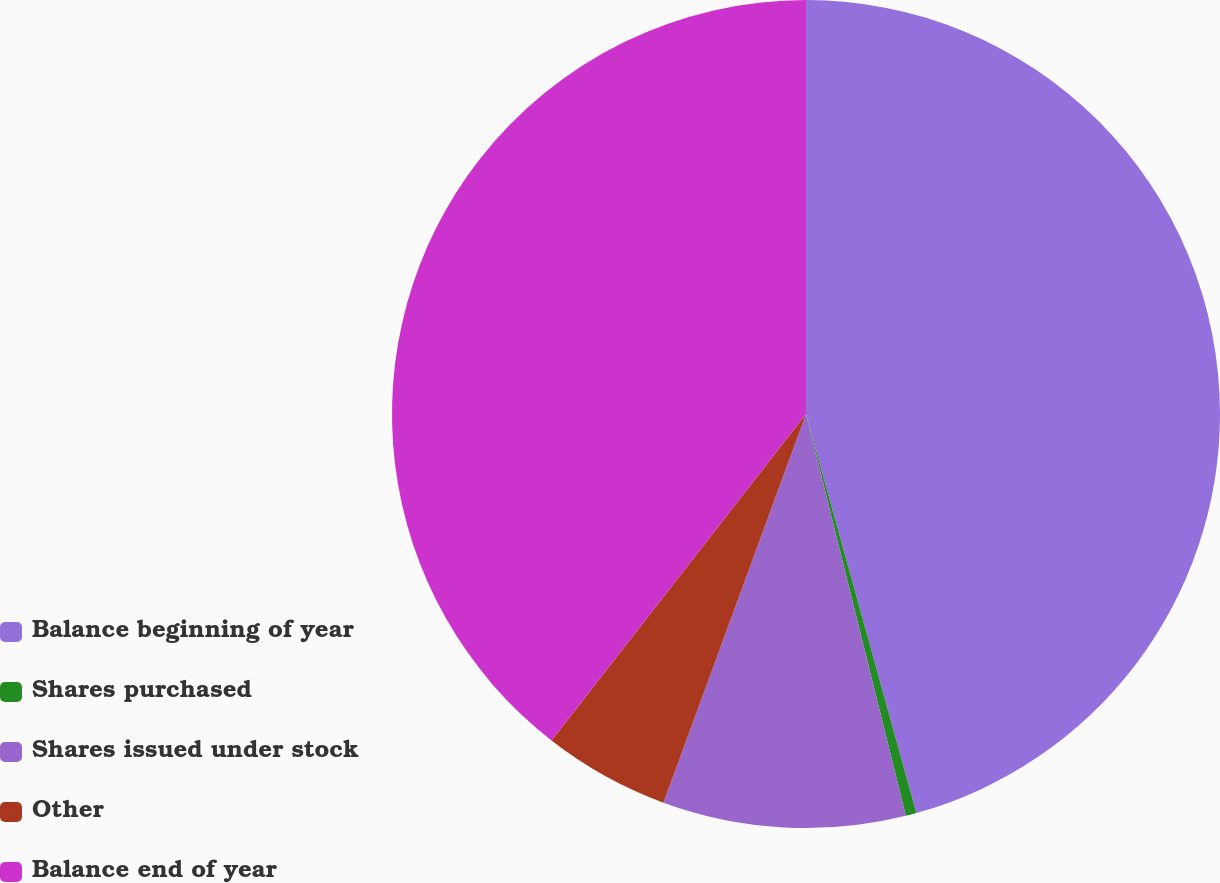Convert chart. <chart><loc_0><loc_0><loc_500><loc_500><pie_chart><fcel>Balance beginning of year<fcel>Shares purchased<fcel>Shares issued under stock<fcel>Other<fcel>Balance end of year<nl><fcel>45.7%<fcel>0.42%<fcel>9.47%<fcel>4.94%<fcel>39.46%<nl></chart> 